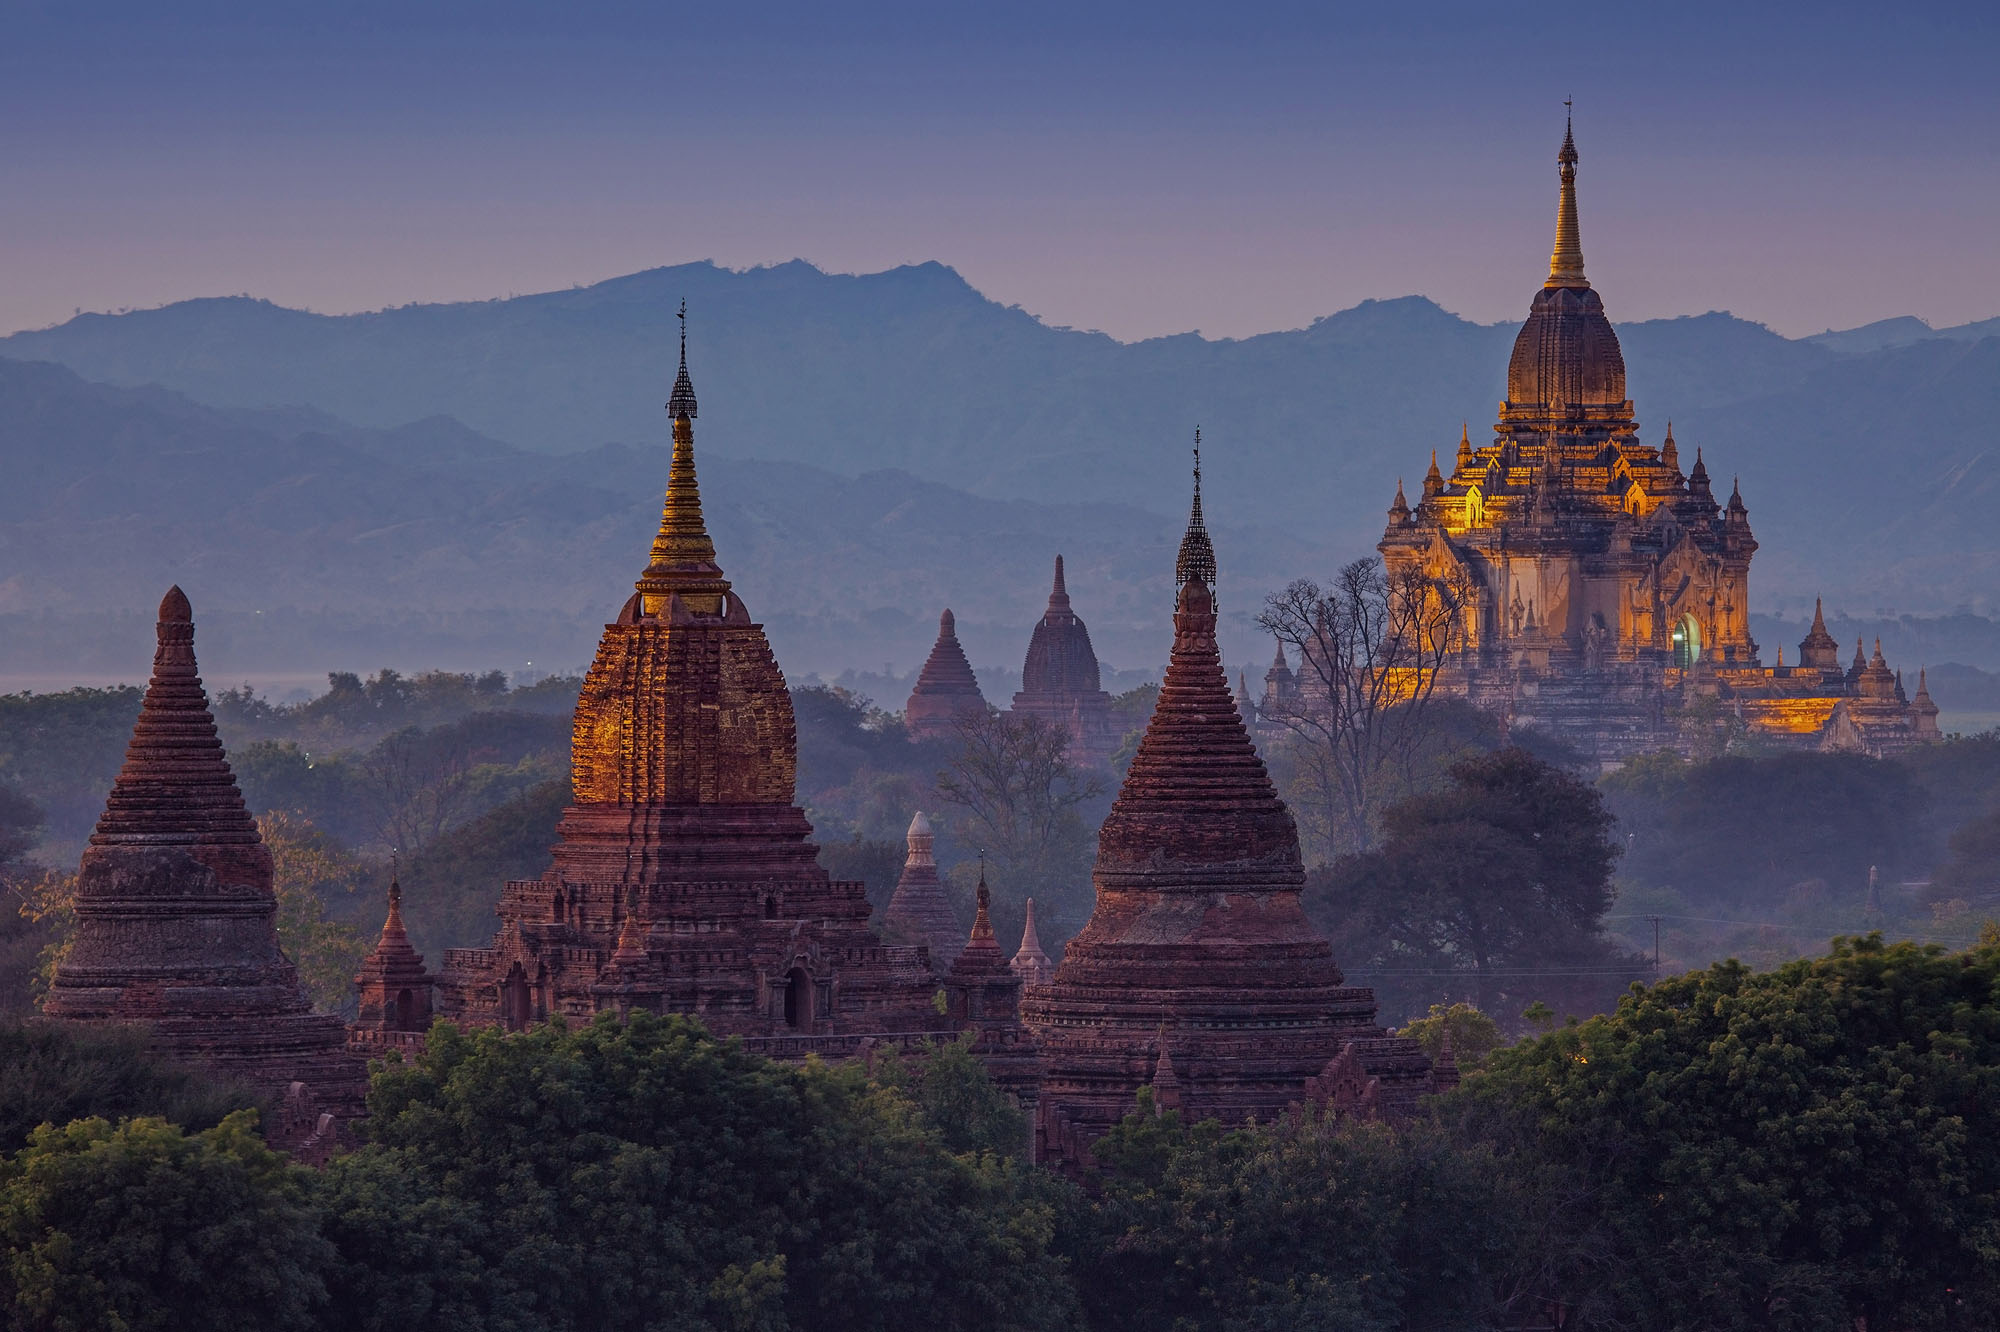How does the landscape influence the experience of visiting Bagan? Bagan's landscape, characterized by flat plains and sporadic hills crowned with temples, creates a breathtaking visual panorama. Visitors often climb to higher vantage points in the cooler early morning or late evening hours to experience sunrise or sunset vistas. The play of light across the myriad of temples, reflecting off the Irrawaddy River, magnifies the profound beauty and scale of Bagan, enhancing the spiritual and sensorial journey of its visitors. 